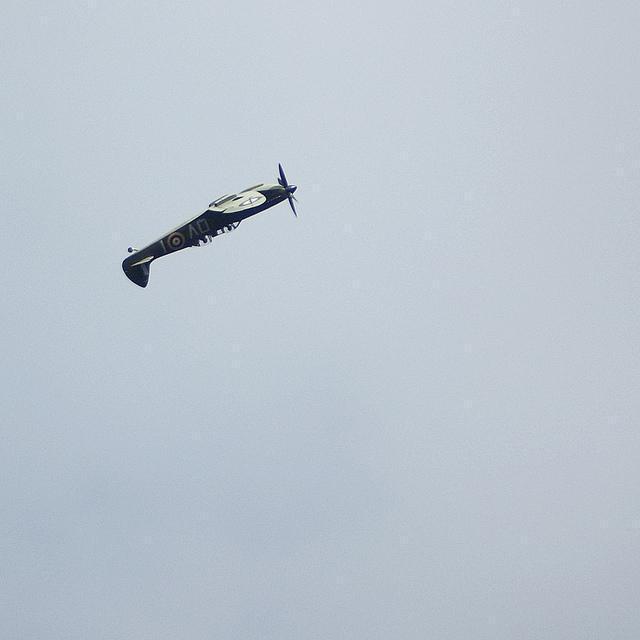How many propellers are shown?
Give a very brief answer. 1. How many airplanes can you see?
Give a very brief answer. 1. How many giraffes are shown?
Give a very brief answer. 0. 